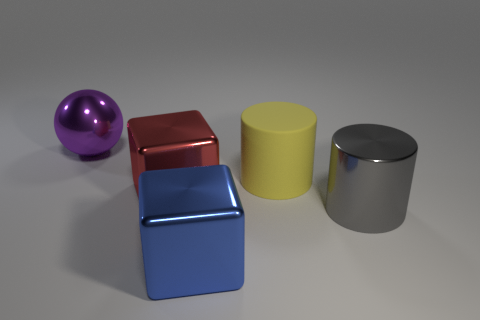What materials appear to be depicted in these objects? The objects in the image seem to be made of different metals, indicated by their reflective surfaces. The sphere has a smooth, shiny purple surface suggesting a metallic paint, while the cube looks to have a brushed metal surface. The yellow cylinder has a matte finish, and the gray cylinder appears to have a mirrored finish, likely stainless steel. 